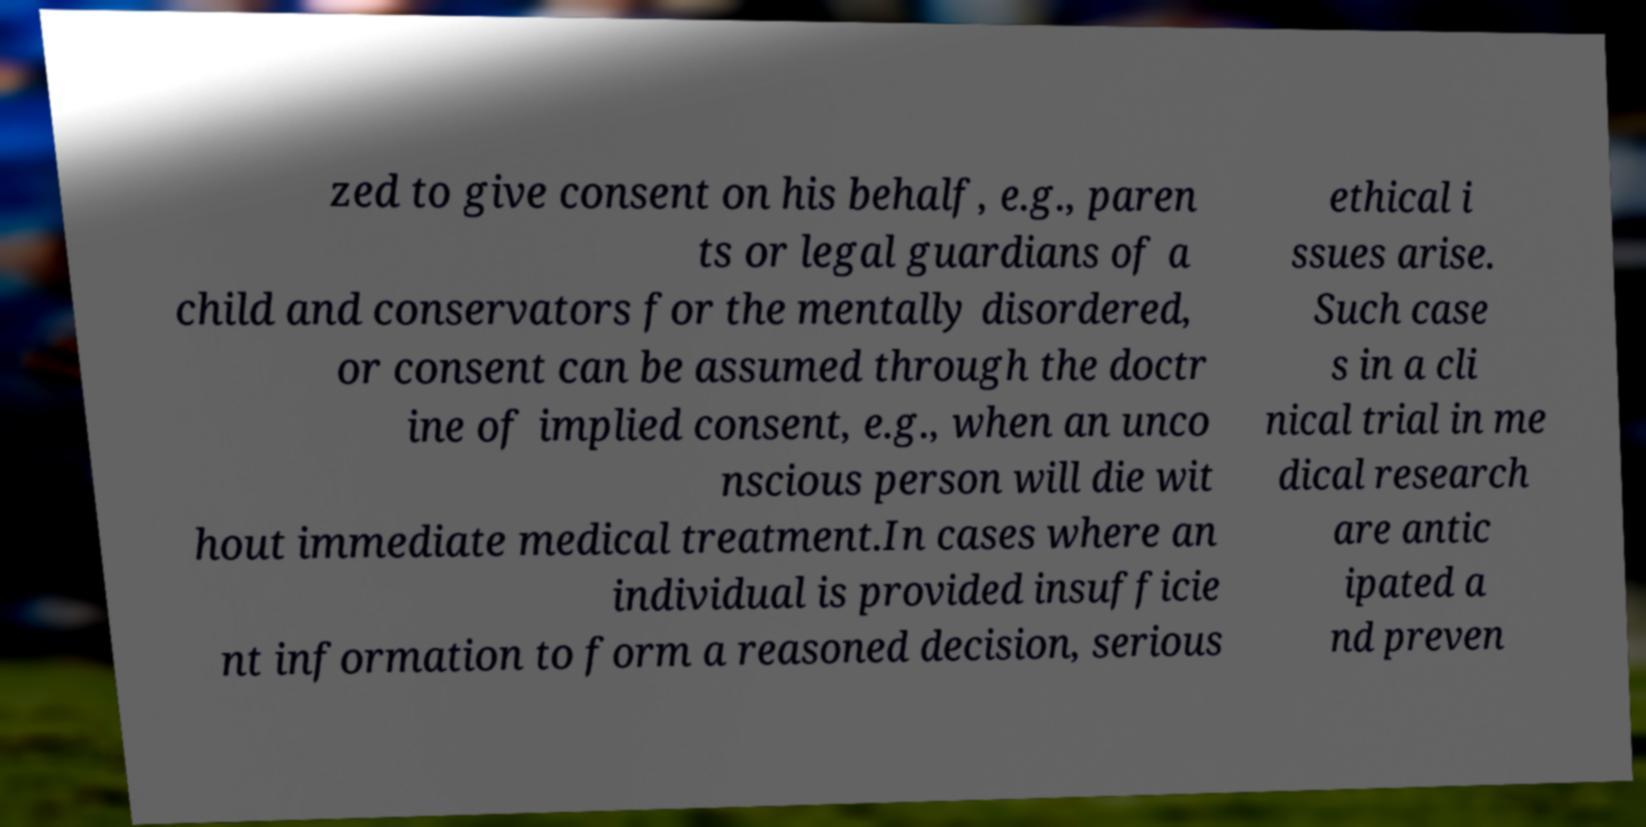Please identify and transcribe the text found in this image. zed to give consent on his behalf, e.g., paren ts or legal guardians of a child and conservators for the mentally disordered, or consent can be assumed through the doctr ine of implied consent, e.g., when an unco nscious person will die wit hout immediate medical treatment.In cases where an individual is provided insufficie nt information to form a reasoned decision, serious ethical i ssues arise. Such case s in a cli nical trial in me dical research are antic ipated a nd preven 